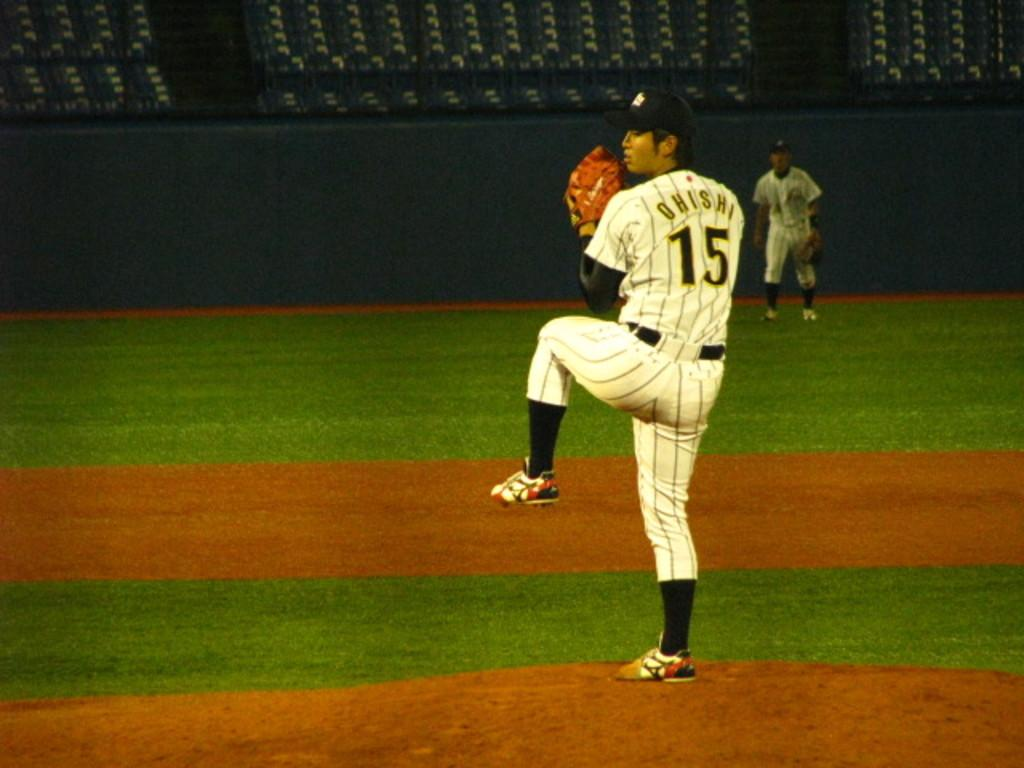<image>
Share a concise interpretation of the image provided. Ohishi, player number 15, prepares to pitch the baseball. 